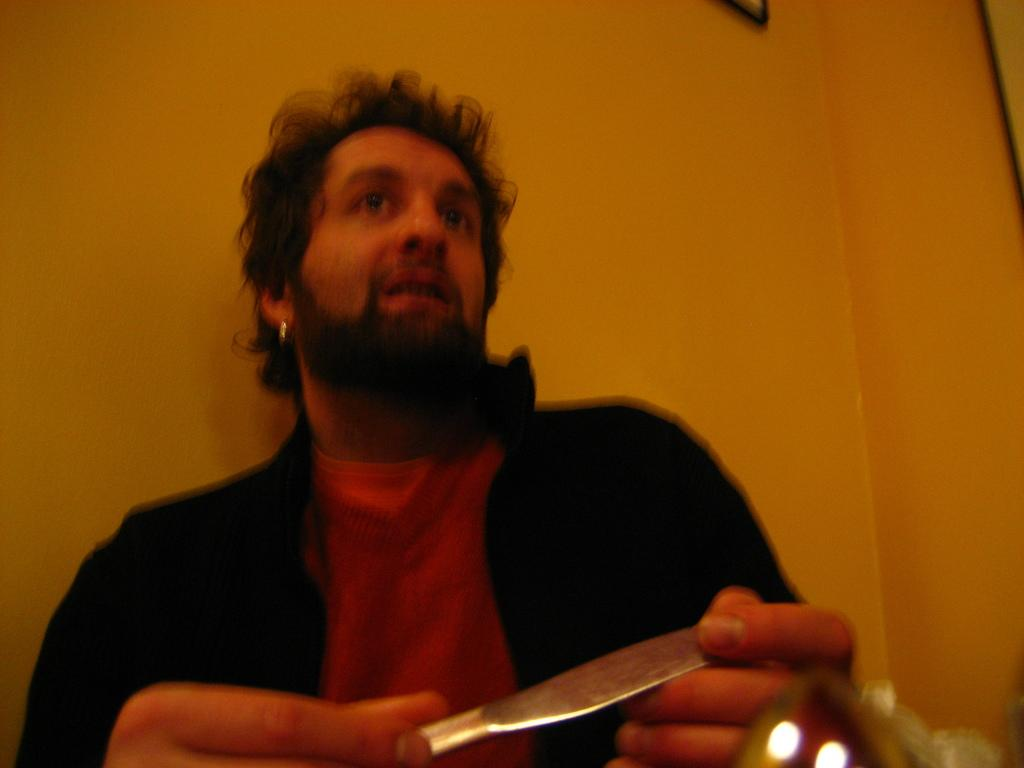What is the person in the image doing? The person is sitting in the image. What object is the person holding in his hand? The person is holding a knife in his hand. What can be seen behind the person in the image? There is a wall visible behind the person. What type of transport is visible in the image? There is no transport visible in the image. What type of rail system is present in the image? There is no rail system present in the image. Where is the person's office located in the image? There is no office present in the image. 